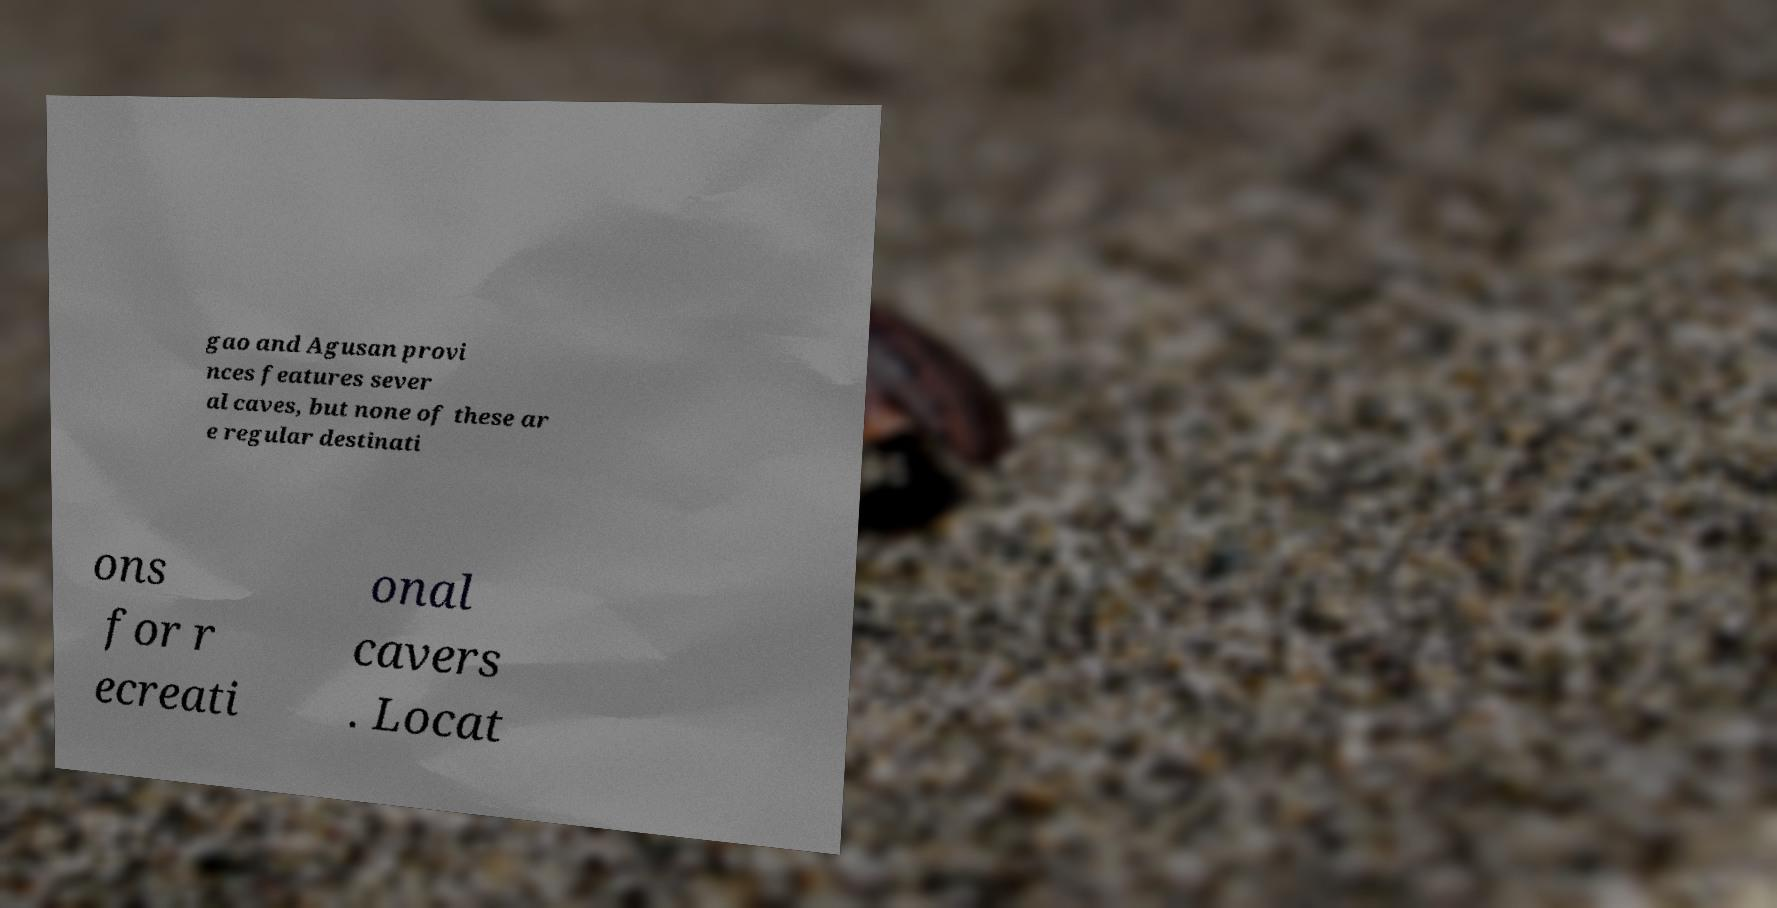Please identify and transcribe the text found in this image. gao and Agusan provi nces features sever al caves, but none of these ar e regular destinati ons for r ecreati onal cavers . Locat 